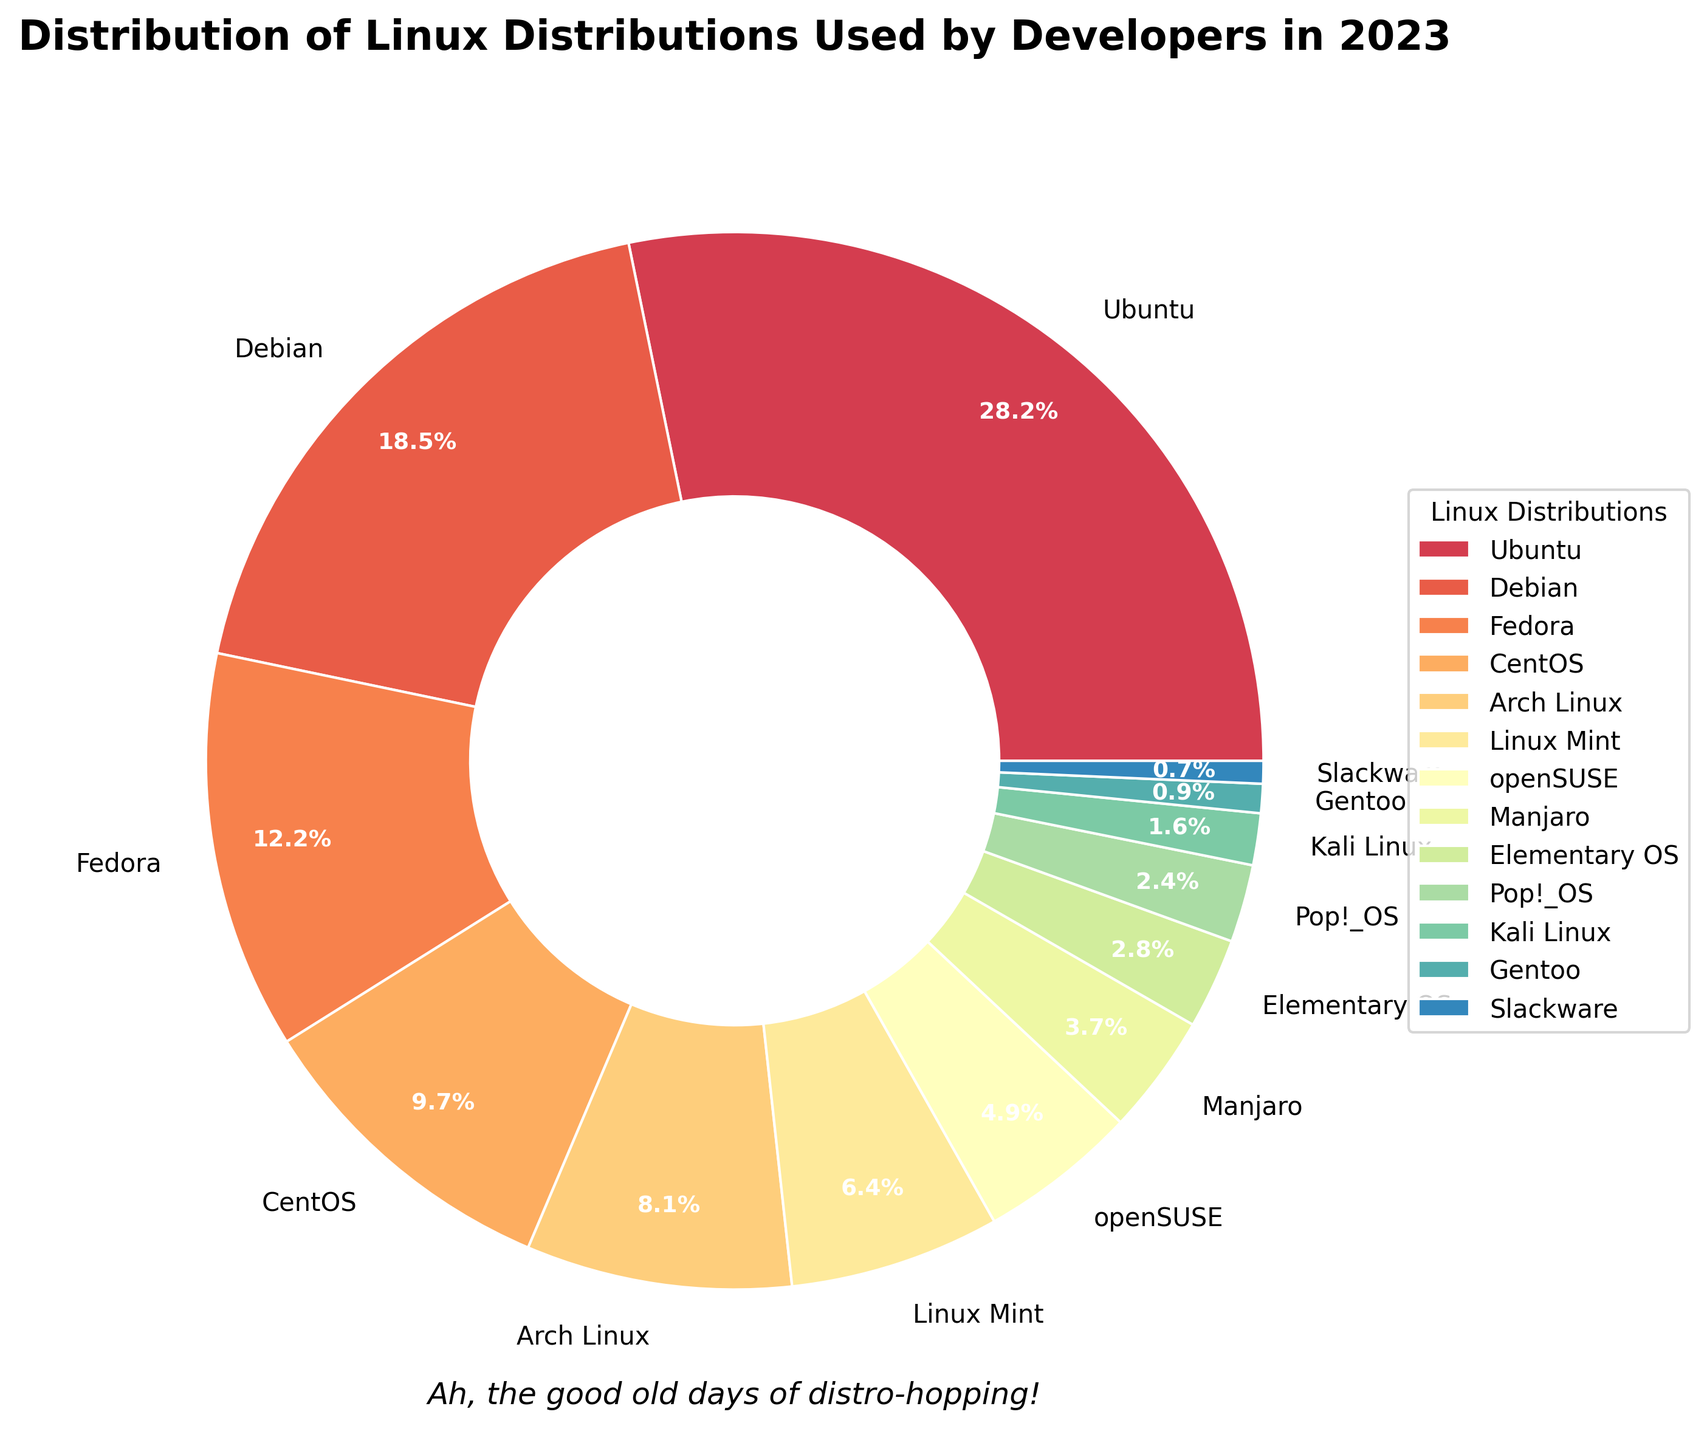What's the most popular Linux distribution among developers in 2023? The pie chart shows various Linux distributions and their respective percentages. The largest slice corresponds to Ubuntu, which makes up 28.5% of the total distribution.
Answer: Ubuntu What is the combined percentage of the top three Linux distributions used by developers? The percentages of the top three Linux distributions are 28.5% for Ubuntu, 18.7% for Debian, and 12.3% for Fedora. Adding them together gives 28.5% + 18.7% + 12.3% = 59.5%.
Answer: 59.5% Which Linux distribution has a larger share, CentOS or Arch Linux? The chart shows that CentOS has 9.8% of the distribution, while Arch Linux has 8.2%. Therefore, CentOS has a larger share than Arch Linux.
Answer: CentOS How much smaller is the share of Pop!_OS compared to Fedora? Fedora has 12.3%, and Pop!_OS has 2.4%. The difference is calculated as 12.3% - 2.4% = 9.9%.
Answer: 9.9% What is the average percentage of the bottom five distributions? The bottom five distributions are Manjaro (3.7%), Elementary OS (2.8%), Pop!_OS (2.4%), Kali Linux (1.6%), and Gentoo (0.9%). The average is calculated as (3.7% + 2.8% + 2.4% + 1.6% + 0.9%) / 5 = 11.4% / 5 = 2.28%.
Answer: 2.28% Which distribution has approximately half the share of Linux Mint? Linux Mint has 6.5%. By examining the chart, we find that openSUSE has 4.9%, which is closest to half of 6.5% (approximately 3.25%). Therefore, none exactly matches half, but openSUSE is higher.
Answer: None, but openSUSE is closest and higher Are there more distributions with shares below 5% or above 5%? By counting, there are six distributions below 5% (Manjaro, Elementary OS, Pop!_OS, Kali Linux, Gentoo, Slackware) and seven distributions above 5% (Ubuntu, Debian, Fedora, CentOS, Arch Linux, Linux Mint, openSUSE). Therefore, there are more distributions with shares above 5%.
Answer: Above 5% What is the ratio of the share of openSUSE to the share of Slackware? openSUSE has 4.9%, and Slackware has 0.7%. The ratio is calculated as 4.9% / 0.7% = 7.
Answer: 7 What percentage does Elementary OS and Pop!_OS make up together? The percentage for Elementary OS is 2.8% and for Pop!_OS is 2.4%. Adding them gives 2.8% + 2.4% = 5.2%.
Answer: 5.2% Which distribution has a third of the share of Debian? Debian has 18.7%. To find a third of it, we calculate 18.7% / 3 = 6.23%. Linux Mint is the closest one with a share of 6.5%, slightly higher than a third of Debian.
Answer: Linux Mint, slightly higher 